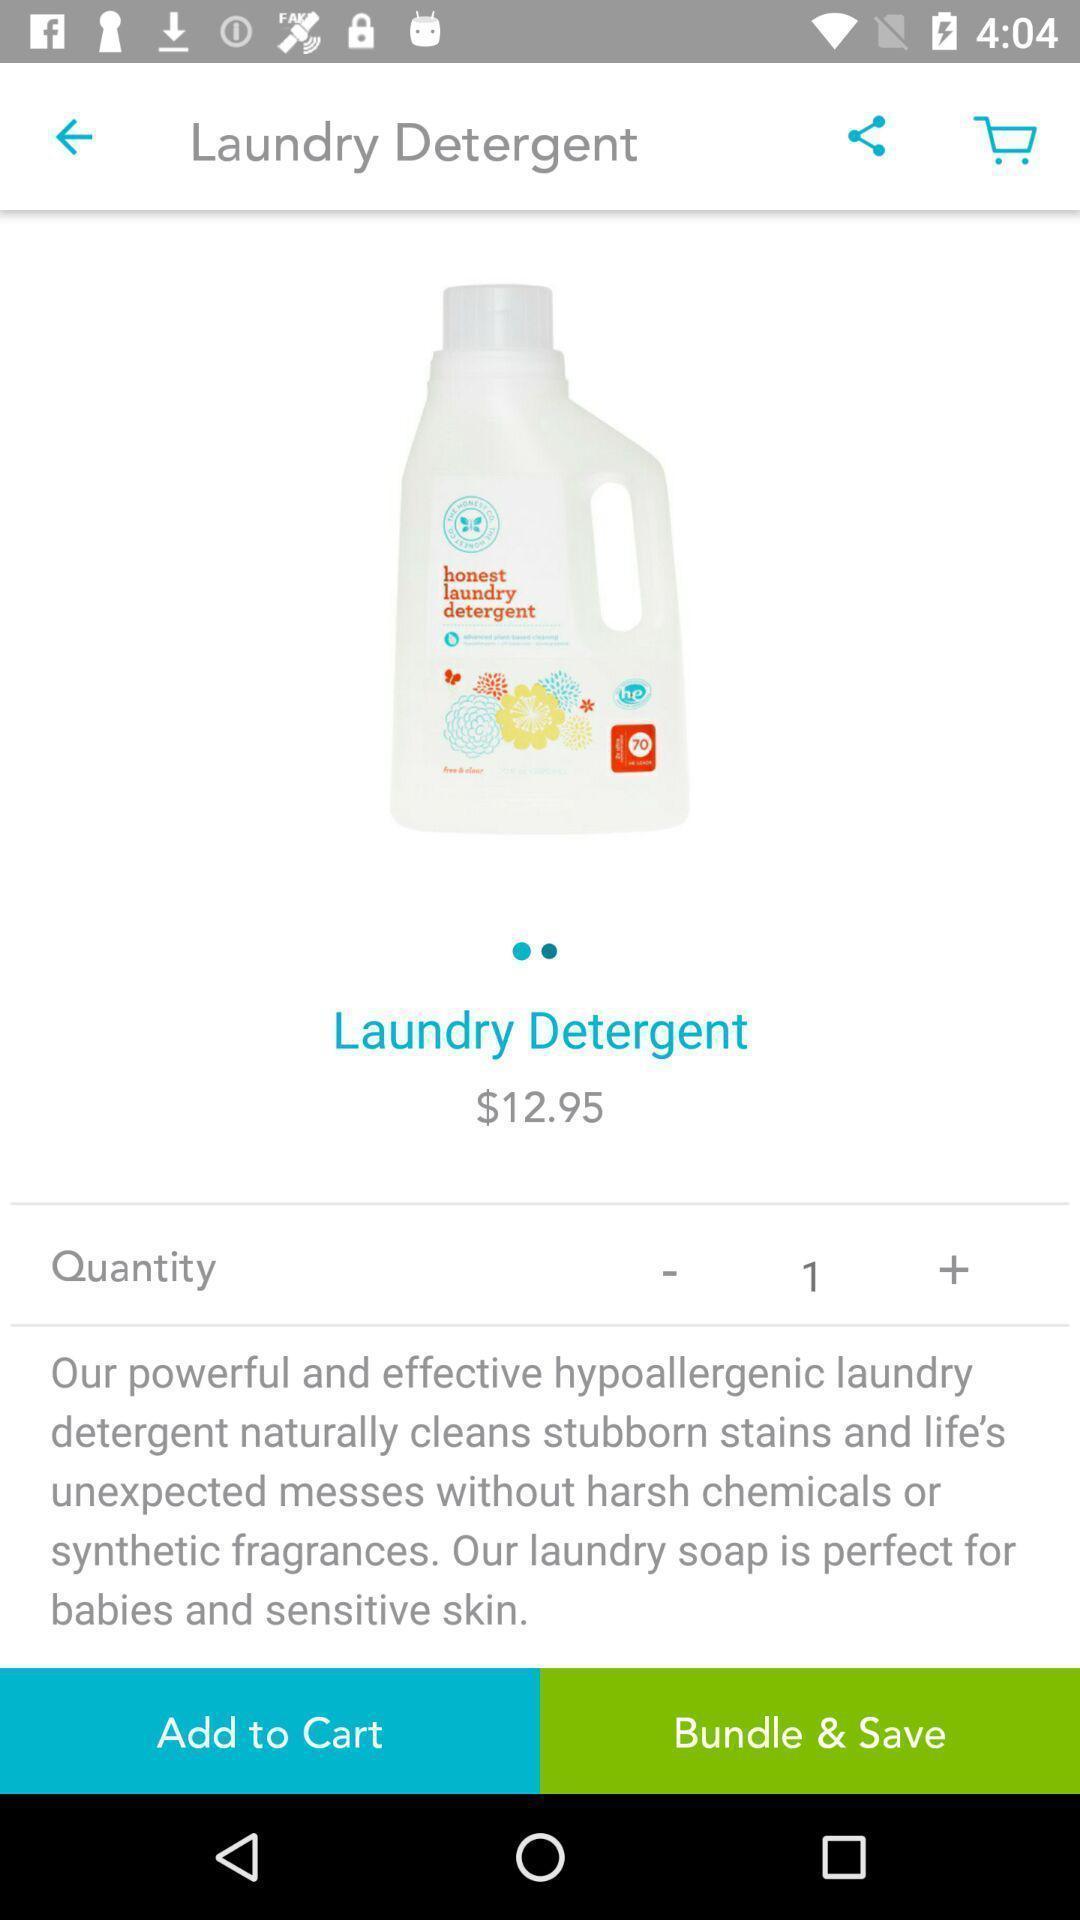What details can you identify in this image? Screen page of a shopping application. 